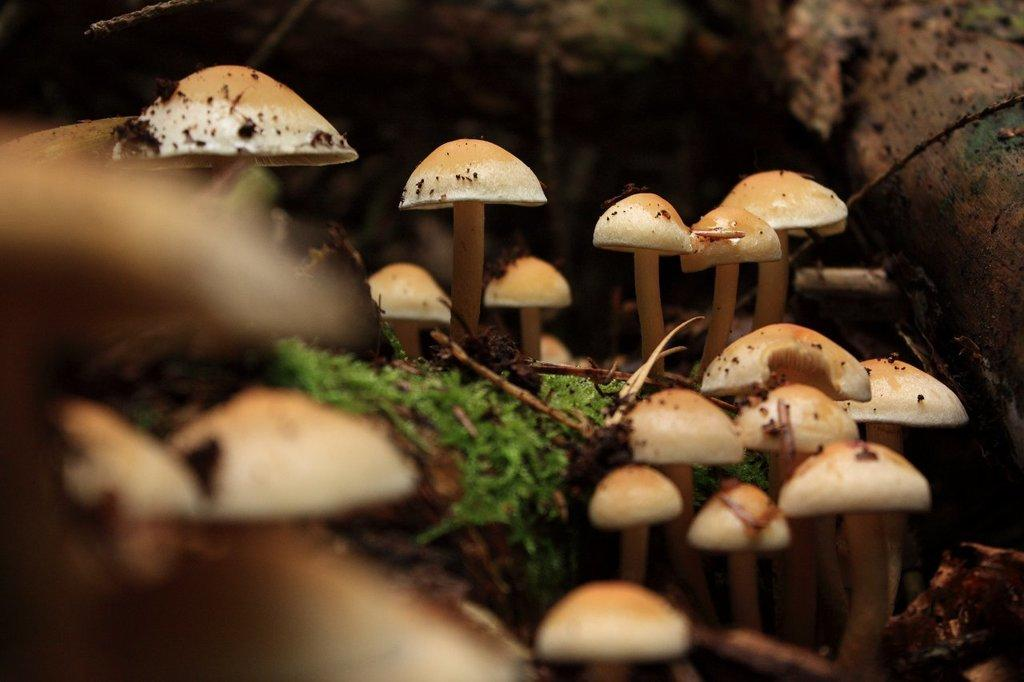What is located in the center of the image? There are mushrooms and grass in the center of the image. Can you describe the background of the image? The background of the image is blurred. How many clams can be seen in the image? There are no clams present in the image. What type of hat is the mushroom wearing in the image? There are no hats present in the image, and mushrooms do not wear hats. 